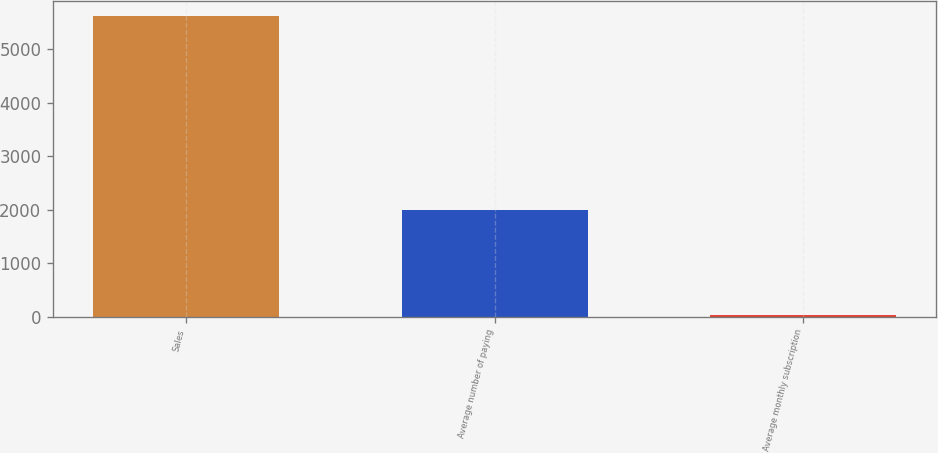Convert chart to OTSL. <chart><loc_0><loc_0><loc_500><loc_500><bar_chart><fcel>Sales<fcel>Average number of paying<fcel>Average monthly subscription<nl><fcel>5617<fcel>1988<fcel>20.98<nl></chart> 